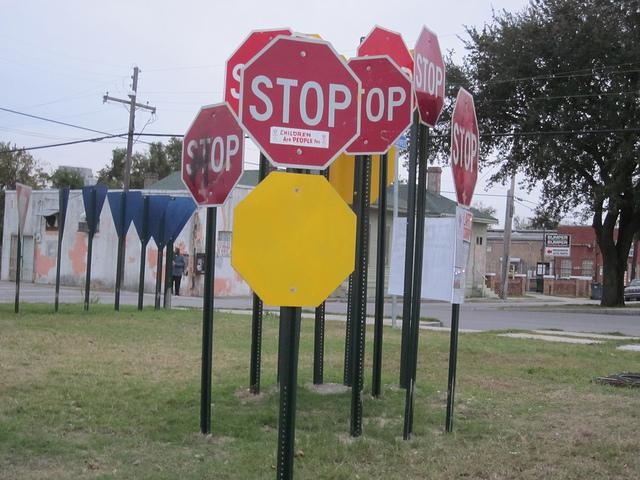What is the purpose of this signage?

Choices:
A) multiple stoppages
B) destruction
C) lightning rods
D) art display art display 